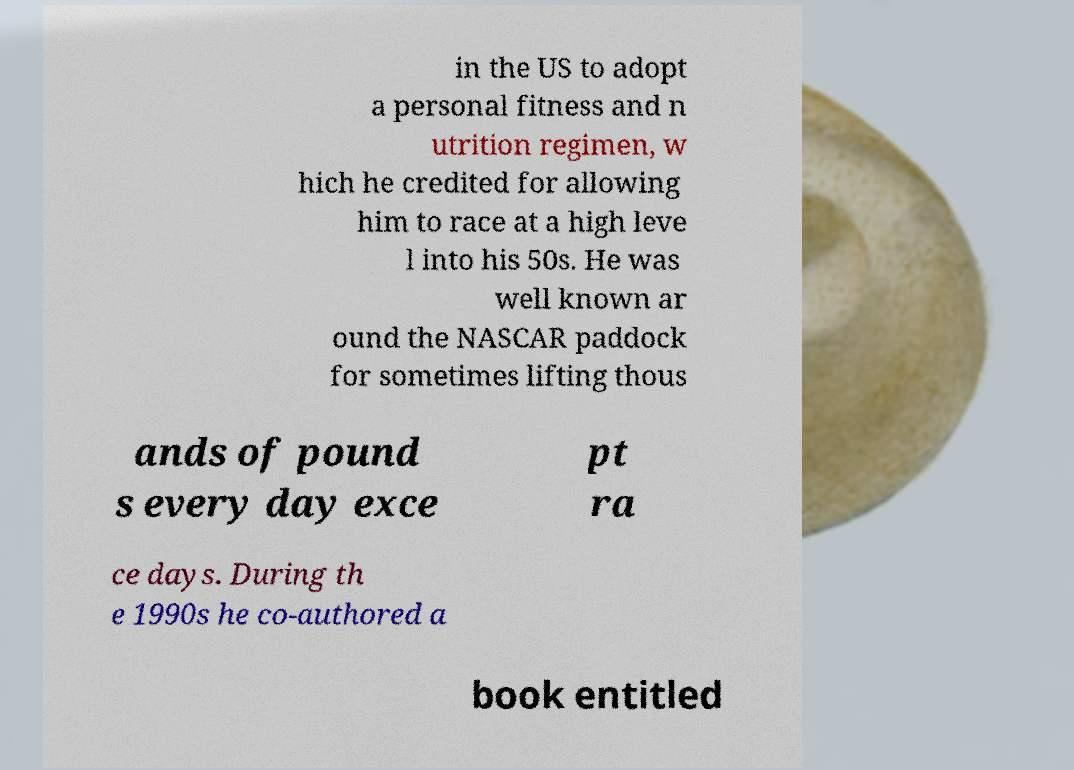For documentation purposes, I need the text within this image transcribed. Could you provide that? in the US to adopt a personal fitness and n utrition regimen, w hich he credited for allowing him to race at a high leve l into his 50s. He was well known ar ound the NASCAR paddock for sometimes lifting thous ands of pound s every day exce pt ra ce days. During th e 1990s he co-authored a book entitled 